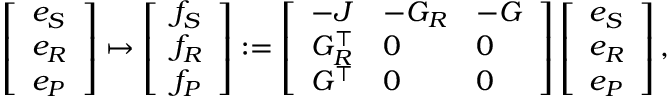<formula> <loc_0><loc_0><loc_500><loc_500>\begin{array} { r } { \left [ \begin{array} { l } { e _ { S } } \\ { e _ { R } } \\ { e _ { P } } \end{array} \right ] \mapsto \left [ \begin{array} { l } { f _ { S } } \\ { f _ { R } } \\ { f _ { P } } \end{array} \right ] \colon = \left [ \begin{array} { l l l } { - J } & { - G _ { R } } & { - G } \\ { G _ { R } ^ { \top } } & { 0 } & { 0 } \\ { G ^ { \top } } & { 0 } & { 0 } \end{array} \right ] \left [ \begin{array} { l } { e _ { S } } \\ { e _ { R } } \\ { e _ { P } } \end{array} \right ] , } \end{array}</formula> 